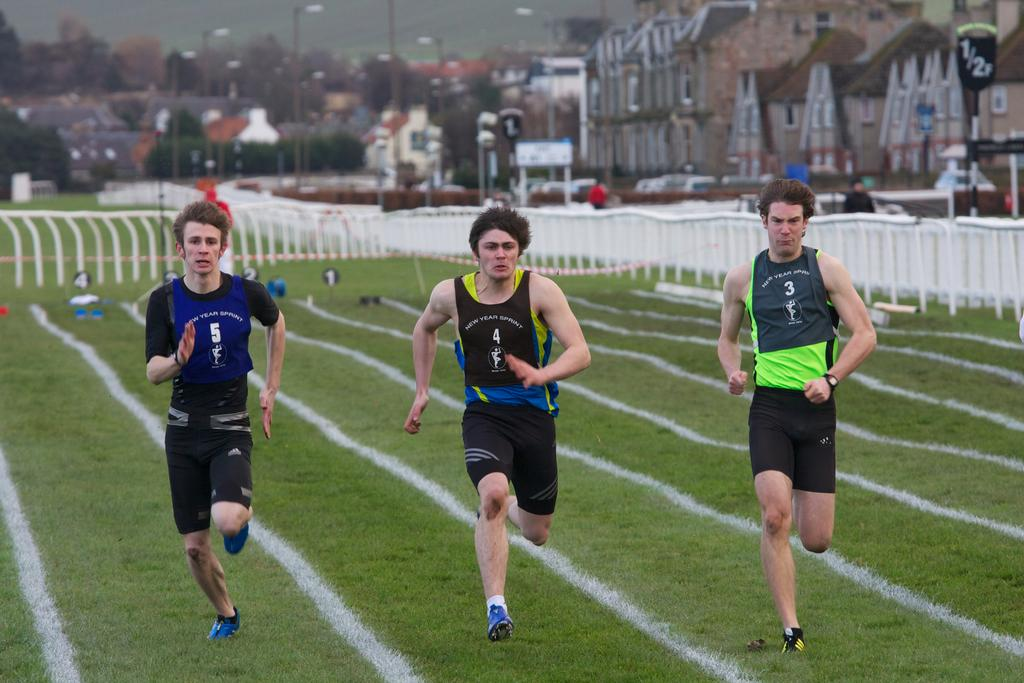<image>
Share a concise interpretation of the image provided. Three boys wearing shirts with the numbers 5, 4, and 3 run in a line. 